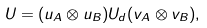<formula> <loc_0><loc_0><loc_500><loc_500>U = ( u _ { A } \otimes u _ { B } ) U _ { d } ( v _ { A } \otimes v _ { B } ) ,</formula> 